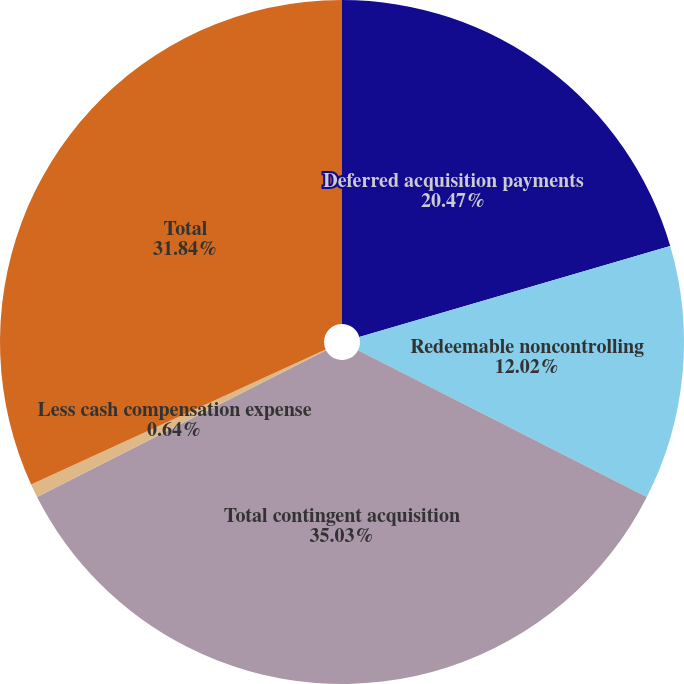<chart> <loc_0><loc_0><loc_500><loc_500><pie_chart><fcel>Deferred acquisition payments<fcel>Redeemable noncontrolling<fcel>Total contingent acquisition<fcel>Less cash compensation expense<fcel>Total<nl><fcel>20.47%<fcel>12.02%<fcel>35.03%<fcel>0.64%<fcel>31.84%<nl></chart> 